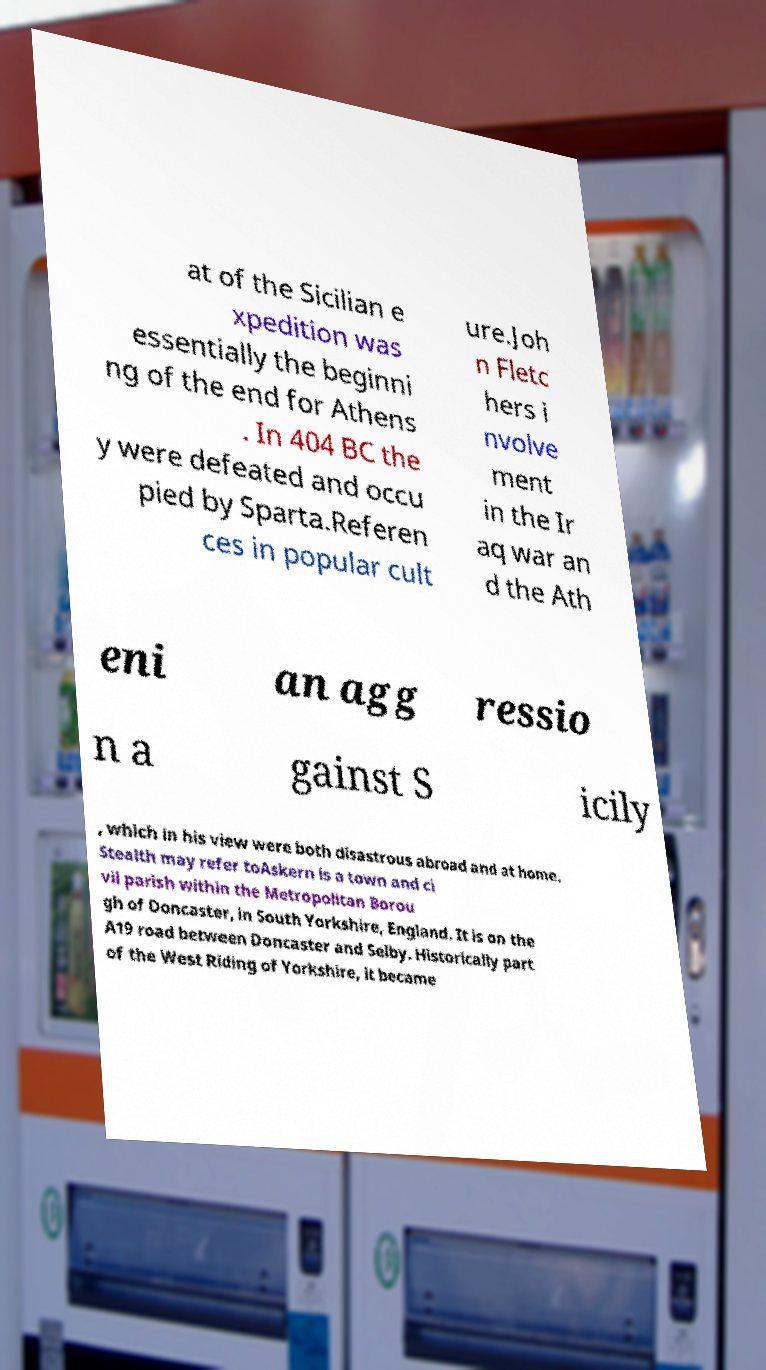Can you read and provide the text displayed in the image?This photo seems to have some interesting text. Can you extract and type it out for me? at of the Sicilian e xpedition was essentially the beginni ng of the end for Athens . In 404 BC the y were defeated and occu pied by Sparta.Referen ces in popular cult ure.Joh n Fletc hers i nvolve ment in the Ir aq war an d the Ath eni an agg ressio n a gainst S icily , which in his view were both disastrous abroad and at home. Stealth may refer toAskern is a town and ci vil parish within the Metropolitan Borou gh of Doncaster, in South Yorkshire, England. It is on the A19 road between Doncaster and Selby. Historically part of the West Riding of Yorkshire, it became 